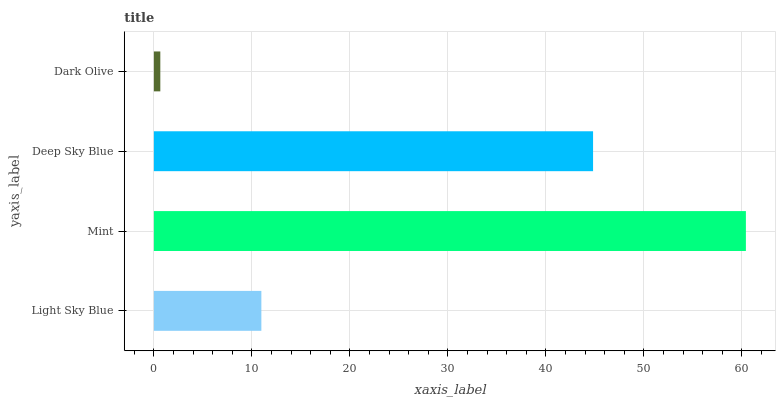Is Dark Olive the minimum?
Answer yes or no. Yes. Is Mint the maximum?
Answer yes or no. Yes. Is Deep Sky Blue the minimum?
Answer yes or no. No. Is Deep Sky Blue the maximum?
Answer yes or no. No. Is Mint greater than Deep Sky Blue?
Answer yes or no. Yes. Is Deep Sky Blue less than Mint?
Answer yes or no. Yes. Is Deep Sky Blue greater than Mint?
Answer yes or no. No. Is Mint less than Deep Sky Blue?
Answer yes or no. No. Is Deep Sky Blue the high median?
Answer yes or no. Yes. Is Light Sky Blue the low median?
Answer yes or no. Yes. Is Light Sky Blue the high median?
Answer yes or no. No. Is Dark Olive the low median?
Answer yes or no. No. 